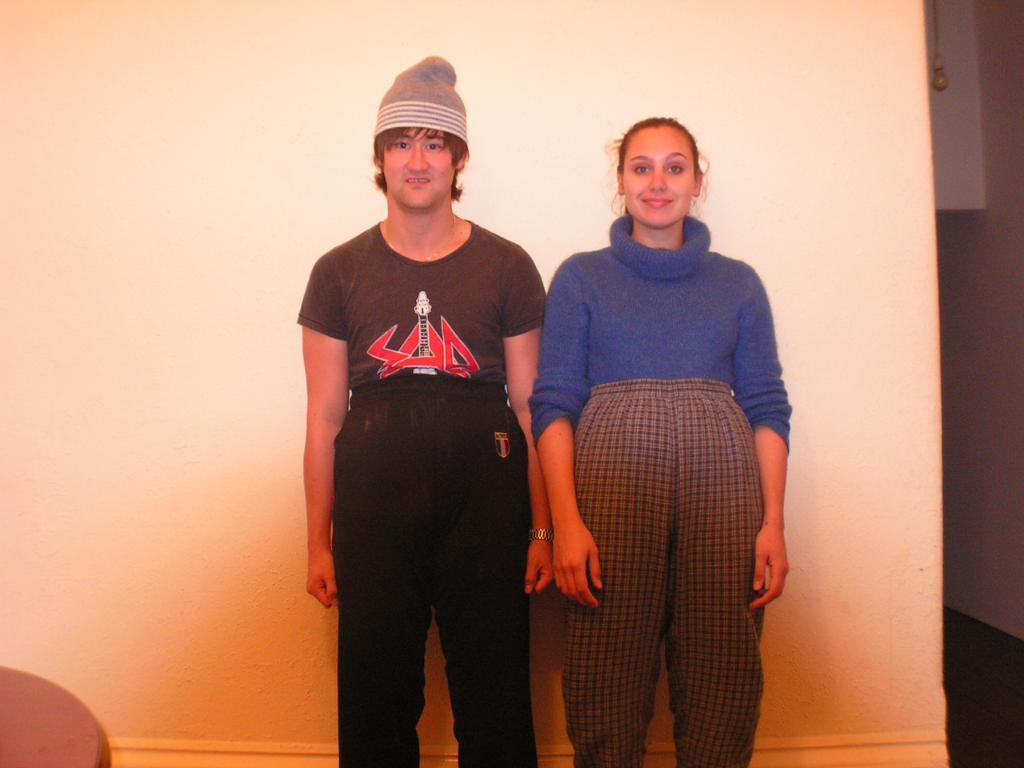Describe this image in one or two sentences. In this image we can see a man and a woman standing beside a wall. On the right side we can see a bulb hanged with a rope. On the left bottom we can see an object. 